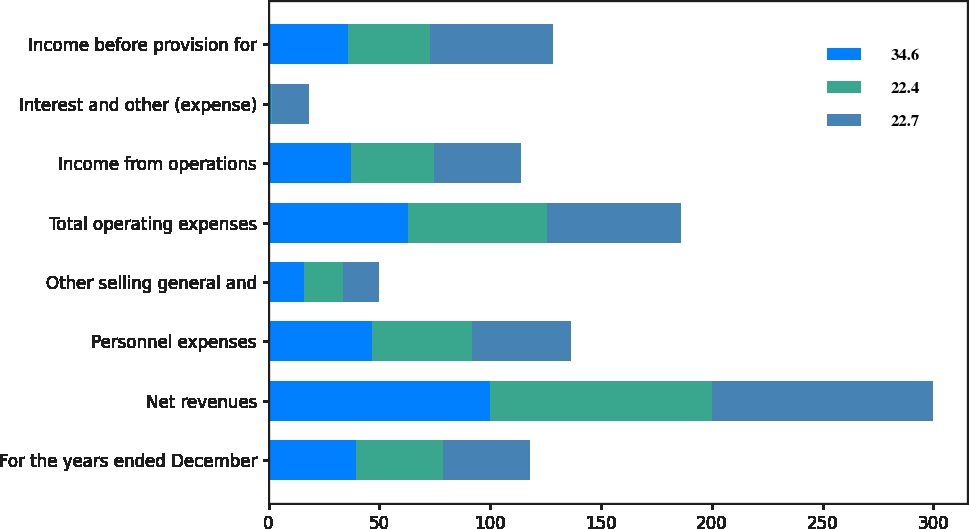Convert chart to OTSL. <chart><loc_0><loc_0><loc_500><loc_500><stacked_bar_chart><ecel><fcel>For the years ended December<fcel>Net revenues<fcel>Personnel expenses<fcel>Other selling general and<fcel>Total operating expenses<fcel>Income from operations<fcel>Interest and other (expense)<fcel>Income before provision for<nl><fcel>34.6<fcel>39.3<fcel>100<fcel>46.8<fcel>15.9<fcel>62.7<fcel>37.3<fcel>1.2<fcel>36<nl><fcel>22.4<fcel>39.3<fcel>100<fcel>45<fcel>17.8<fcel>62.8<fcel>37.2<fcel>0.5<fcel>36.7<nl><fcel>22.7<fcel>39.3<fcel>100<fcel>44.6<fcel>16.1<fcel>60.7<fcel>39.3<fcel>16.5<fcel>55.8<nl></chart> 